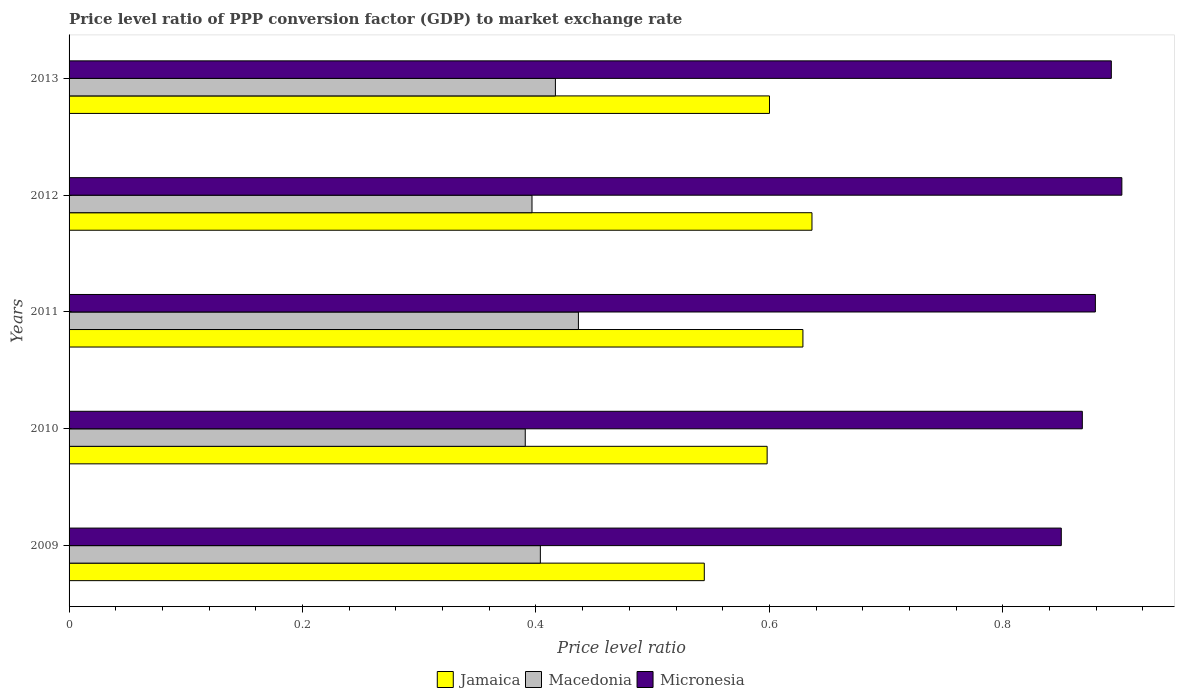How many different coloured bars are there?
Provide a succinct answer. 3. How many groups of bars are there?
Make the answer very short. 5. Are the number of bars on each tick of the Y-axis equal?
Provide a short and direct response. Yes. How many bars are there on the 5th tick from the top?
Offer a very short reply. 3. How many bars are there on the 5th tick from the bottom?
Keep it short and to the point. 3. What is the label of the 2nd group of bars from the top?
Your answer should be compact. 2012. In how many cases, is the number of bars for a given year not equal to the number of legend labels?
Your answer should be very brief. 0. What is the price level ratio in Micronesia in 2012?
Give a very brief answer. 0.9. Across all years, what is the maximum price level ratio in Macedonia?
Keep it short and to the point. 0.44. Across all years, what is the minimum price level ratio in Macedonia?
Offer a very short reply. 0.39. What is the total price level ratio in Jamaica in the graph?
Provide a short and direct response. 3.01. What is the difference between the price level ratio in Micronesia in 2009 and that in 2013?
Your response must be concise. -0.04. What is the difference between the price level ratio in Macedonia in 2010 and the price level ratio in Micronesia in 2012?
Provide a short and direct response. -0.51. What is the average price level ratio in Micronesia per year?
Your answer should be very brief. 0.88. In the year 2013, what is the difference between the price level ratio in Macedonia and price level ratio in Jamaica?
Keep it short and to the point. -0.18. What is the ratio of the price level ratio in Jamaica in 2009 to that in 2013?
Give a very brief answer. 0.91. Is the difference between the price level ratio in Macedonia in 2011 and 2012 greater than the difference between the price level ratio in Jamaica in 2011 and 2012?
Offer a very short reply. Yes. What is the difference between the highest and the second highest price level ratio in Micronesia?
Make the answer very short. 0.01. What is the difference between the highest and the lowest price level ratio in Micronesia?
Offer a very short reply. 0.05. In how many years, is the price level ratio in Macedonia greater than the average price level ratio in Macedonia taken over all years?
Offer a very short reply. 2. Is the sum of the price level ratio in Jamaica in 2010 and 2013 greater than the maximum price level ratio in Micronesia across all years?
Offer a terse response. Yes. What does the 1st bar from the top in 2010 represents?
Your answer should be very brief. Micronesia. What does the 2nd bar from the bottom in 2009 represents?
Your response must be concise. Macedonia. Is it the case that in every year, the sum of the price level ratio in Jamaica and price level ratio in Micronesia is greater than the price level ratio in Macedonia?
Your response must be concise. Yes. How many bars are there?
Offer a terse response. 15. Are all the bars in the graph horizontal?
Your answer should be very brief. Yes. How many years are there in the graph?
Your answer should be compact. 5. Are the values on the major ticks of X-axis written in scientific E-notation?
Offer a terse response. No. Does the graph contain any zero values?
Offer a terse response. No. How are the legend labels stacked?
Offer a very short reply. Horizontal. What is the title of the graph?
Keep it short and to the point. Price level ratio of PPP conversion factor (GDP) to market exchange rate. Does "Pakistan" appear as one of the legend labels in the graph?
Offer a very short reply. No. What is the label or title of the X-axis?
Provide a short and direct response. Price level ratio. What is the Price level ratio of Jamaica in 2009?
Make the answer very short. 0.54. What is the Price level ratio in Macedonia in 2009?
Provide a succinct answer. 0.4. What is the Price level ratio in Micronesia in 2009?
Keep it short and to the point. 0.85. What is the Price level ratio of Jamaica in 2010?
Offer a very short reply. 0.6. What is the Price level ratio in Macedonia in 2010?
Give a very brief answer. 0.39. What is the Price level ratio in Micronesia in 2010?
Ensure brevity in your answer.  0.87. What is the Price level ratio of Jamaica in 2011?
Ensure brevity in your answer.  0.63. What is the Price level ratio in Macedonia in 2011?
Ensure brevity in your answer.  0.44. What is the Price level ratio of Micronesia in 2011?
Provide a succinct answer. 0.88. What is the Price level ratio of Jamaica in 2012?
Provide a short and direct response. 0.64. What is the Price level ratio in Macedonia in 2012?
Provide a succinct answer. 0.4. What is the Price level ratio in Micronesia in 2012?
Offer a very short reply. 0.9. What is the Price level ratio in Jamaica in 2013?
Give a very brief answer. 0.6. What is the Price level ratio in Macedonia in 2013?
Your answer should be very brief. 0.42. What is the Price level ratio in Micronesia in 2013?
Provide a short and direct response. 0.89. Across all years, what is the maximum Price level ratio in Jamaica?
Your answer should be compact. 0.64. Across all years, what is the maximum Price level ratio of Macedonia?
Make the answer very short. 0.44. Across all years, what is the maximum Price level ratio in Micronesia?
Provide a short and direct response. 0.9. Across all years, what is the minimum Price level ratio of Jamaica?
Ensure brevity in your answer.  0.54. Across all years, what is the minimum Price level ratio in Macedonia?
Provide a succinct answer. 0.39. Across all years, what is the minimum Price level ratio of Micronesia?
Keep it short and to the point. 0.85. What is the total Price level ratio of Jamaica in the graph?
Your response must be concise. 3.01. What is the total Price level ratio of Macedonia in the graph?
Give a very brief answer. 2.04. What is the total Price level ratio of Micronesia in the graph?
Ensure brevity in your answer.  4.39. What is the difference between the Price level ratio of Jamaica in 2009 and that in 2010?
Your answer should be very brief. -0.05. What is the difference between the Price level ratio of Macedonia in 2009 and that in 2010?
Your answer should be compact. 0.01. What is the difference between the Price level ratio in Micronesia in 2009 and that in 2010?
Provide a succinct answer. -0.02. What is the difference between the Price level ratio of Jamaica in 2009 and that in 2011?
Ensure brevity in your answer.  -0.08. What is the difference between the Price level ratio of Macedonia in 2009 and that in 2011?
Provide a short and direct response. -0.03. What is the difference between the Price level ratio in Micronesia in 2009 and that in 2011?
Offer a terse response. -0.03. What is the difference between the Price level ratio of Jamaica in 2009 and that in 2012?
Make the answer very short. -0.09. What is the difference between the Price level ratio of Macedonia in 2009 and that in 2012?
Offer a very short reply. 0.01. What is the difference between the Price level ratio in Micronesia in 2009 and that in 2012?
Offer a very short reply. -0.05. What is the difference between the Price level ratio of Jamaica in 2009 and that in 2013?
Give a very brief answer. -0.06. What is the difference between the Price level ratio of Macedonia in 2009 and that in 2013?
Your answer should be compact. -0.01. What is the difference between the Price level ratio of Micronesia in 2009 and that in 2013?
Your answer should be very brief. -0.04. What is the difference between the Price level ratio of Jamaica in 2010 and that in 2011?
Offer a terse response. -0.03. What is the difference between the Price level ratio in Macedonia in 2010 and that in 2011?
Offer a terse response. -0.05. What is the difference between the Price level ratio in Micronesia in 2010 and that in 2011?
Your answer should be very brief. -0.01. What is the difference between the Price level ratio in Jamaica in 2010 and that in 2012?
Provide a succinct answer. -0.04. What is the difference between the Price level ratio of Macedonia in 2010 and that in 2012?
Give a very brief answer. -0.01. What is the difference between the Price level ratio in Micronesia in 2010 and that in 2012?
Offer a very short reply. -0.03. What is the difference between the Price level ratio in Jamaica in 2010 and that in 2013?
Offer a terse response. -0. What is the difference between the Price level ratio in Macedonia in 2010 and that in 2013?
Your answer should be compact. -0.03. What is the difference between the Price level ratio in Micronesia in 2010 and that in 2013?
Your response must be concise. -0.02. What is the difference between the Price level ratio of Jamaica in 2011 and that in 2012?
Offer a very short reply. -0.01. What is the difference between the Price level ratio in Macedonia in 2011 and that in 2012?
Offer a terse response. 0.04. What is the difference between the Price level ratio in Micronesia in 2011 and that in 2012?
Offer a very short reply. -0.02. What is the difference between the Price level ratio of Jamaica in 2011 and that in 2013?
Offer a terse response. 0.03. What is the difference between the Price level ratio of Macedonia in 2011 and that in 2013?
Your answer should be compact. 0.02. What is the difference between the Price level ratio of Micronesia in 2011 and that in 2013?
Ensure brevity in your answer.  -0.01. What is the difference between the Price level ratio in Jamaica in 2012 and that in 2013?
Offer a very short reply. 0.04. What is the difference between the Price level ratio of Macedonia in 2012 and that in 2013?
Ensure brevity in your answer.  -0.02. What is the difference between the Price level ratio of Micronesia in 2012 and that in 2013?
Your answer should be compact. 0.01. What is the difference between the Price level ratio of Jamaica in 2009 and the Price level ratio of Macedonia in 2010?
Provide a succinct answer. 0.15. What is the difference between the Price level ratio in Jamaica in 2009 and the Price level ratio in Micronesia in 2010?
Ensure brevity in your answer.  -0.32. What is the difference between the Price level ratio of Macedonia in 2009 and the Price level ratio of Micronesia in 2010?
Provide a short and direct response. -0.46. What is the difference between the Price level ratio of Jamaica in 2009 and the Price level ratio of Macedonia in 2011?
Offer a very short reply. 0.11. What is the difference between the Price level ratio in Jamaica in 2009 and the Price level ratio in Micronesia in 2011?
Offer a terse response. -0.34. What is the difference between the Price level ratio in Macedonia in 2009 and the Price level ratio in Micronesia in 2011?
Ensure brevity in your answer.  -0.48. What is the difference between the Price level ratio of Jamaica in 2009 and the Price level ratio of Macedonia in 2012?
Your response must be concise. 0.15. What is the difference between the Price level ratio in Jamaica in 2009 and the Price level ratio in Micronesia in 2012?
Keep it short and to the point. -0.36. What is the difference between the Price level ratio in Macedonia in 2009 and the Price level ratio in Micronesia in 2012?
Make the answer very short. -0.5. What is the difference between the Price level ratio in Jamaica in 2009 and the Price level ratio in Macedonia in 2013?
Ensure brevity in your answer.  0.13. What is the difference between the Price level ratio of Jamaica in 2009 and the Price level ratio of Micronesia in 2013?
Offer a very short reply. -0.35. What is the difference between the Price level ratio in Macedonia in 2009 and the Price level ratio in Micronesia in 2013?
Provide a succinct answer. -0.49. What is the difference between the Price level ratio of Jamaica in 2010 and the Price level ratio of Macedonia in 2011?
Provide a succinct answer. 0.16. What is the difference between the Price level ratio in Jamaica in 2010 and the Price level ratio in Micronesia in 2011?
Make the answer very short. -0.28. What is the difference between the Price level ratio of Macedonia in 2010 and the Price level ratio of Micronesia in 2011?
Your answer should be compact. -0.49. What is the difference between the Price level ratio in Jamaica in 2010 and the Price level ratio in Macedonia in 2012?
Offer a very short reply. 0.2. What is the difference between the Price level ratio of Jamaica in 2010 and the Price level ratio of Micronesia in 2012?
Offer a very short reply. -0.3. What is the difference between the Price level ratio in Macedonia in 2010 and the Price level ratio in Micronesia in 2012?
Give a very brief answer. -0.51. What is the difference between the Price level ratio in Jamaica in 2010 and the Price level ratio in Macedonia in 2013?
Offer a terse response. 0.18. What is the difference between the Price level ratio in Jamaica in 2010 and the Price level ratio in Micronesia in 2013?
Give a very brief answer. -0.29. What is the difference between the Price level ratio of Macedonia in 2010 and the Price level ratio of Micronesia in 2013?
Keep it short and to the point. -0.5. What is the difference between the Price level ratio of Jamaica in 2011 and the Price level ratio of Macedonia in 2012?
Your answer should be very brief. 0.23. What is the difference between the Price level ratio in Jamaica in 2011 and the Price level ratio in Micronesia in 2012?
Give a very brief answer. -0.27. What is the difference between the Price level ratio in Macedonia in 2011 and the Price level ratio in Micronesia in 2012?
Keep it short and to the point. -0.47. What is the difference between the Price level ratio in Jamaica in 2011 and the Price level ratio in Macedonia in 2013?
Ensure brevity in your answer.  0.21. What is the difference between the Price level ratio of Jamaica in 2011 and the Price level ratio of Micronesia in 2013?
Make the answer very short. -0.26. What is the difference between the Price level ratio of Macedonia in 2011 and the Price level ratio of Micronesia in 2013?
Offer a very short reply. -0.46. What is the difference between the Price level ratio in Jamaica in 2012 and the Price level ratio in Macedonia in 2013?
Offer a terse response. 0.22. What is the difference between the Price level ratio of Jamaica in 2012 and the Price level ratio of Micronesia in 2013?
Ensure brevity in your answer.  -0.26. What is the difference between the Price level ratio of Macedonia in 2012 and the Price level ratio of Micronesia in 2013?
Your answer should be compact. -0.5. What is the average Price level ratio in Jamaica per year?
Offer a terse response. 0.6. What is the average Price level ratio of Macedonia per year?
Your answer should be very brief. 0.41. What is the average Price level ratio in Micronesia per year?
Your response must be concise. 0.88. In the year 2009, what is the difference between the Price level ratio of Jamaica and Price level ratio of Macedonia?
Your response must be concise. 0.14. In the year 2009, what is the difference between the Price level ratio in Jamaica and Price level ratio in Micronesia?
Offer a terse response. -0.31. In the year 2009, what is the difference between the Price level ratio of Macedonia and Price level ratio of Micronesia?
Provide a short and direct response. -0.45. In the year 2010, what is the difference between the Price level ratio of Jamaica and Price level ratio of Macedonia?
Your answer should be compact. 0.21. In the year 2010, what is the difference between the Price level ratio in Jamaica and Price level ratio in Micronesia?
Offer a very short reply. -0.27. In the year 2010, what is the difference between the Price level ratio of Macedonia and Price level ratio of Micronesia?
Offer a very short reply. -0.48. In the year 2011, what is the difference between the Price level ratio of Jamaica and Price level ratio of Macedonia?
Ensure brevity in your answer.  0.19. In the year 2011, what is the difference between the Price level ratio in Jamaica and Price level ratio in Micronesia?
Offer a terse response. -0.25. In the year 2011, what is the difference between the Price level ratio of Macedonia and Price level ratio of Micronesia?
Make the answer very short. -0.44. In the year 2012, what is the difference between the Price level ratio of Jamaica and Price level ratio of Macedonia?
Your answer should be very brief. 0.24. In the year 2012, what is the difference between the Price level ratio of Jamaica and Price level ratio of Micronesia?
Keep it short and to the point. -0.27. In the year 2012, what is the difference between the Price level ratio of Macedonia and Price level ratio of Micronesia?
Keep it short and to the point. -0.51. In the year 2013, what is the difference between the Price level ratio in Jamaica and Price level ratio in Macedonia?
Offer a terse response. 0.18. In the year 2013, what is the difference between the Price level ratio of Jamaica and Price level ratio of Micronesia?
Your answer should be very brief. -0.29. In the year 2013, what is the difference between the Price level ratio of Macedonia and Price level ratio of Micronesia?
Provide a succinct answer. -0.48. What is the ratio of the Price level ratio of Jamaica in 2009 to that in 2010?
Make the answer very short. 0.91. What is the ratio of the Price level ratio in Macedonia in 2009 to that in 2010?
Make the answer very short. 1.03. What is the ratio of the Price level ratio in Micronesia in 2009 to that in 2010?
Provide a short and direct response. 0.98. What is the ratio of the Price level ratio in Jamaica in 2009 to that in 2011?
Provide a succinct answer. 0.87. What is the ratio of the Price level ratio in Macedonia in 2009 to that in 2011?
Your answer should be very brief. 0.93. What is the ratio of the Price level ratio of Micronesia in 2009 to that in 2011?
Offer a terse response. 0.97. What is the ratio of the Price level ratio of Jamaica in 2009 to that in 2012?
Ensure brevity in your answer.  0.86. What is the ratio of the Price level ratio of Macedonia in 2009 to that in 2012?
Your answer should be compact. 1.02. What is the ratio of the Price level ratio of Micronesia in 2009 to that in 2012?
Give a very brief answer. 0.94. What is the ratio of the Price level ratio in Jamaica in 2009 to that in 2013?
Your answer should be compact. 0.91. What is the ratio of the Price level ratio in Macedonia in 2009 to that in 2013?
Offer a very short reply. 0.97. What is the ratio of the Price level ratio of Jamaica in 2010 to that in 2011?
Offer a very short reply. 0.95. What is the ratio of the Price level ratio in Macedonia in 2010 to that in 2011?
Your answer should be very brief. 0.9. What is the ratio of the Price level ratio of Micronesia in 2010 to that in 2011?
Ensure brevity in your answer.  0.99. What is the ratio of the Price level ratio in Jamaica in 2010 to that in 2012?
Provide a short and direct response. 0.94. What is the ratio of the Price level ratio in Macedonia in 2010 to that in 2012?
Offer a terse response. 0.99. What is the ratio of the Price level ratio in Micronesia in 2010 to that in 2012?
Offer a terse response. 0.96. What is the ratio of the Price level ratio in Macedonia in 2010 to that in 2013?
Offer a very short reply. 0.94. What is the ratio of the Price level ratio of Micronesia in 2010 to that in 2013?
Your answer should be very brief. 0.97. What is the ratio of the Price level ratio of Macedonia in 2011 to that in 2012?
Provide a short and direct response. 1.1. What is the ratio of the Price level ratio in Micronesia in 2011 to that in 2012?
Offer a very short reply. 0.97. What is the ratio of the Price level ratio of Jamaica in 2011 to that in 2013?
Keep it short and to the point. 1.05. What is the ratio of the Price level ratio of Macedonia in 2011 to that in 2013?
Offer a very short reply. 1.05. What is the ratio of the Price level ratio in Micronesia in 2011 to that in 2013?
Provide a short and direct response. 0.98. What is the ratio of the Price level ratio in Jamaica in 2012 to that in 2013?
Your answer should be compact. 1.06. What is the ratio of the Price level ratio of Macedonia in 2012 to that in 2013?
Your answer should be very brief. 0.95. What is the ratio of the Price level ratio of Micronesia in 2012 to that in 2013?
Ensure brevity in your answer.  1.01. What is the difference between the highest and the second highest Price level ratio of Jamaica?
Keep it short and to the point. 0.01. What is the difference between the highest and the second highest Price level ratio of Macedonia?
Make the answer very short. 0.02. What is the difference between the highest and the second highest Price level ratio of Micronesia?
Your answer should be compact. 0.01. What is the difference between the highest and the lowest Price level ratio in Jamaica?
Keep it short and to the point. 0.09. What is the difference between the highest and the lowest Price level ratio in Macedonia?
Offer a terse response. 0.05. What is the difference between the highest and the lowest Price level ratio of Micronesia?
Offer a terse response. 0.05. 